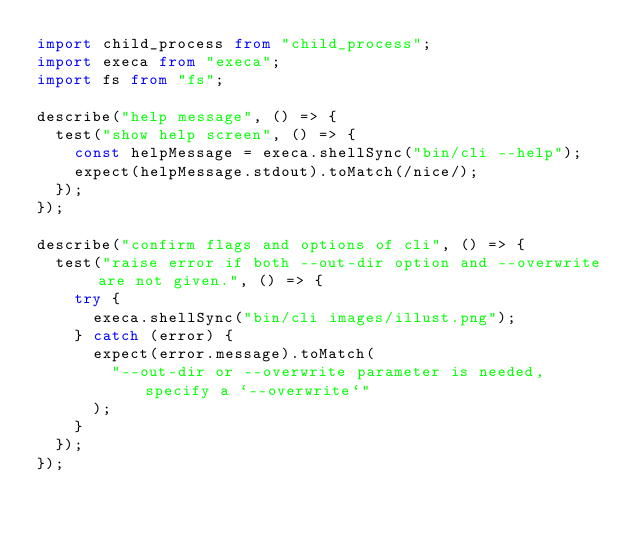Convert code to text. <code><loc_0><loc_0><loc_500><loc_500><_TypeScript_>import child_process from "child_process";
import execa from "execa";
import fs from "fs";

describe("help message", () => {
  test("show help screen", () => {
    const helpMessage = execa.shellSync("bin/cli --help");
    expect(helpMessage.stdout).toMatch(/nice/);
  });
});

describe("confirm flags and options of cli", () => {
  test("raise error if both --out-dir option and --overwrite are not given.", () => {
    try {
      execa.shellSync("bin/cli images/illust.png");
    } catch (error) {
      expect(error.message).toMatch(
        "--out-dir or --overwrite parameter is needed, specify a `--overwrite`"
      );
    }
  });
});
</code> 